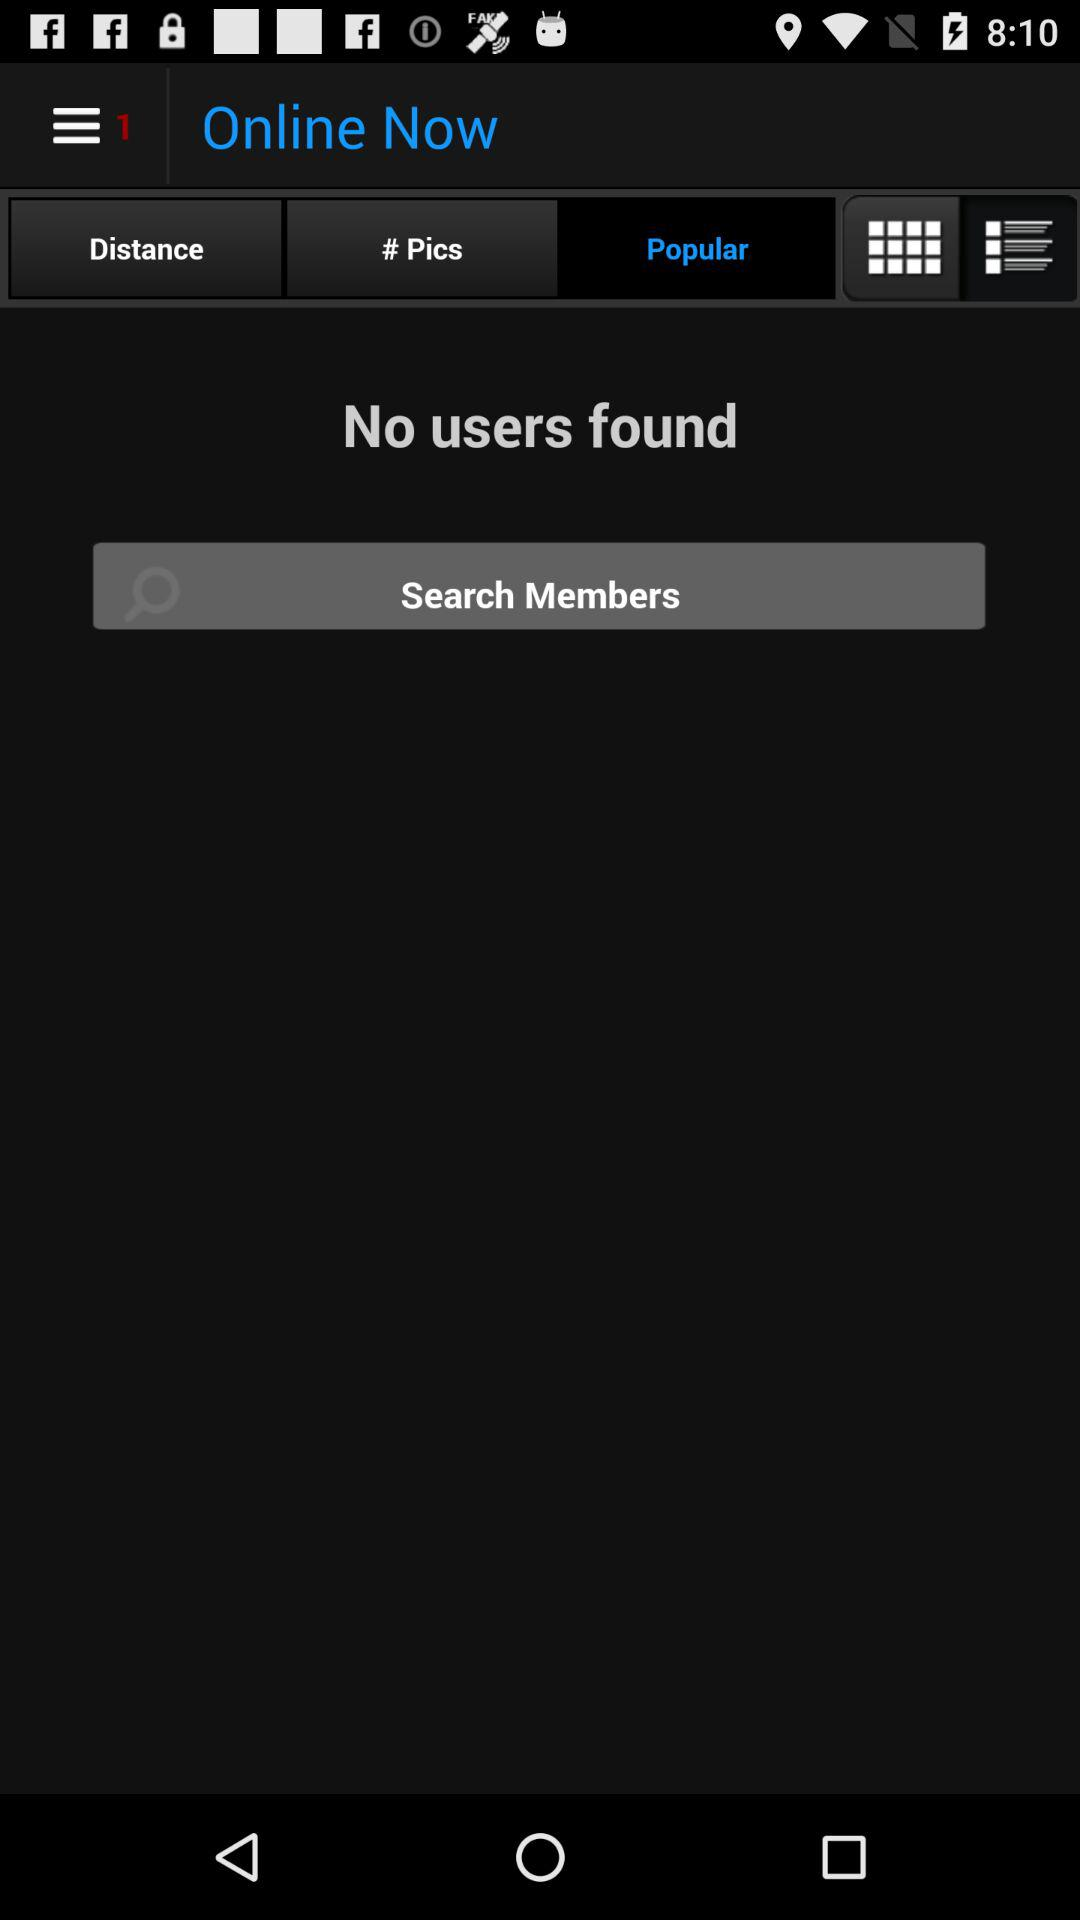Which option is selected? The selected option is "Popular". 